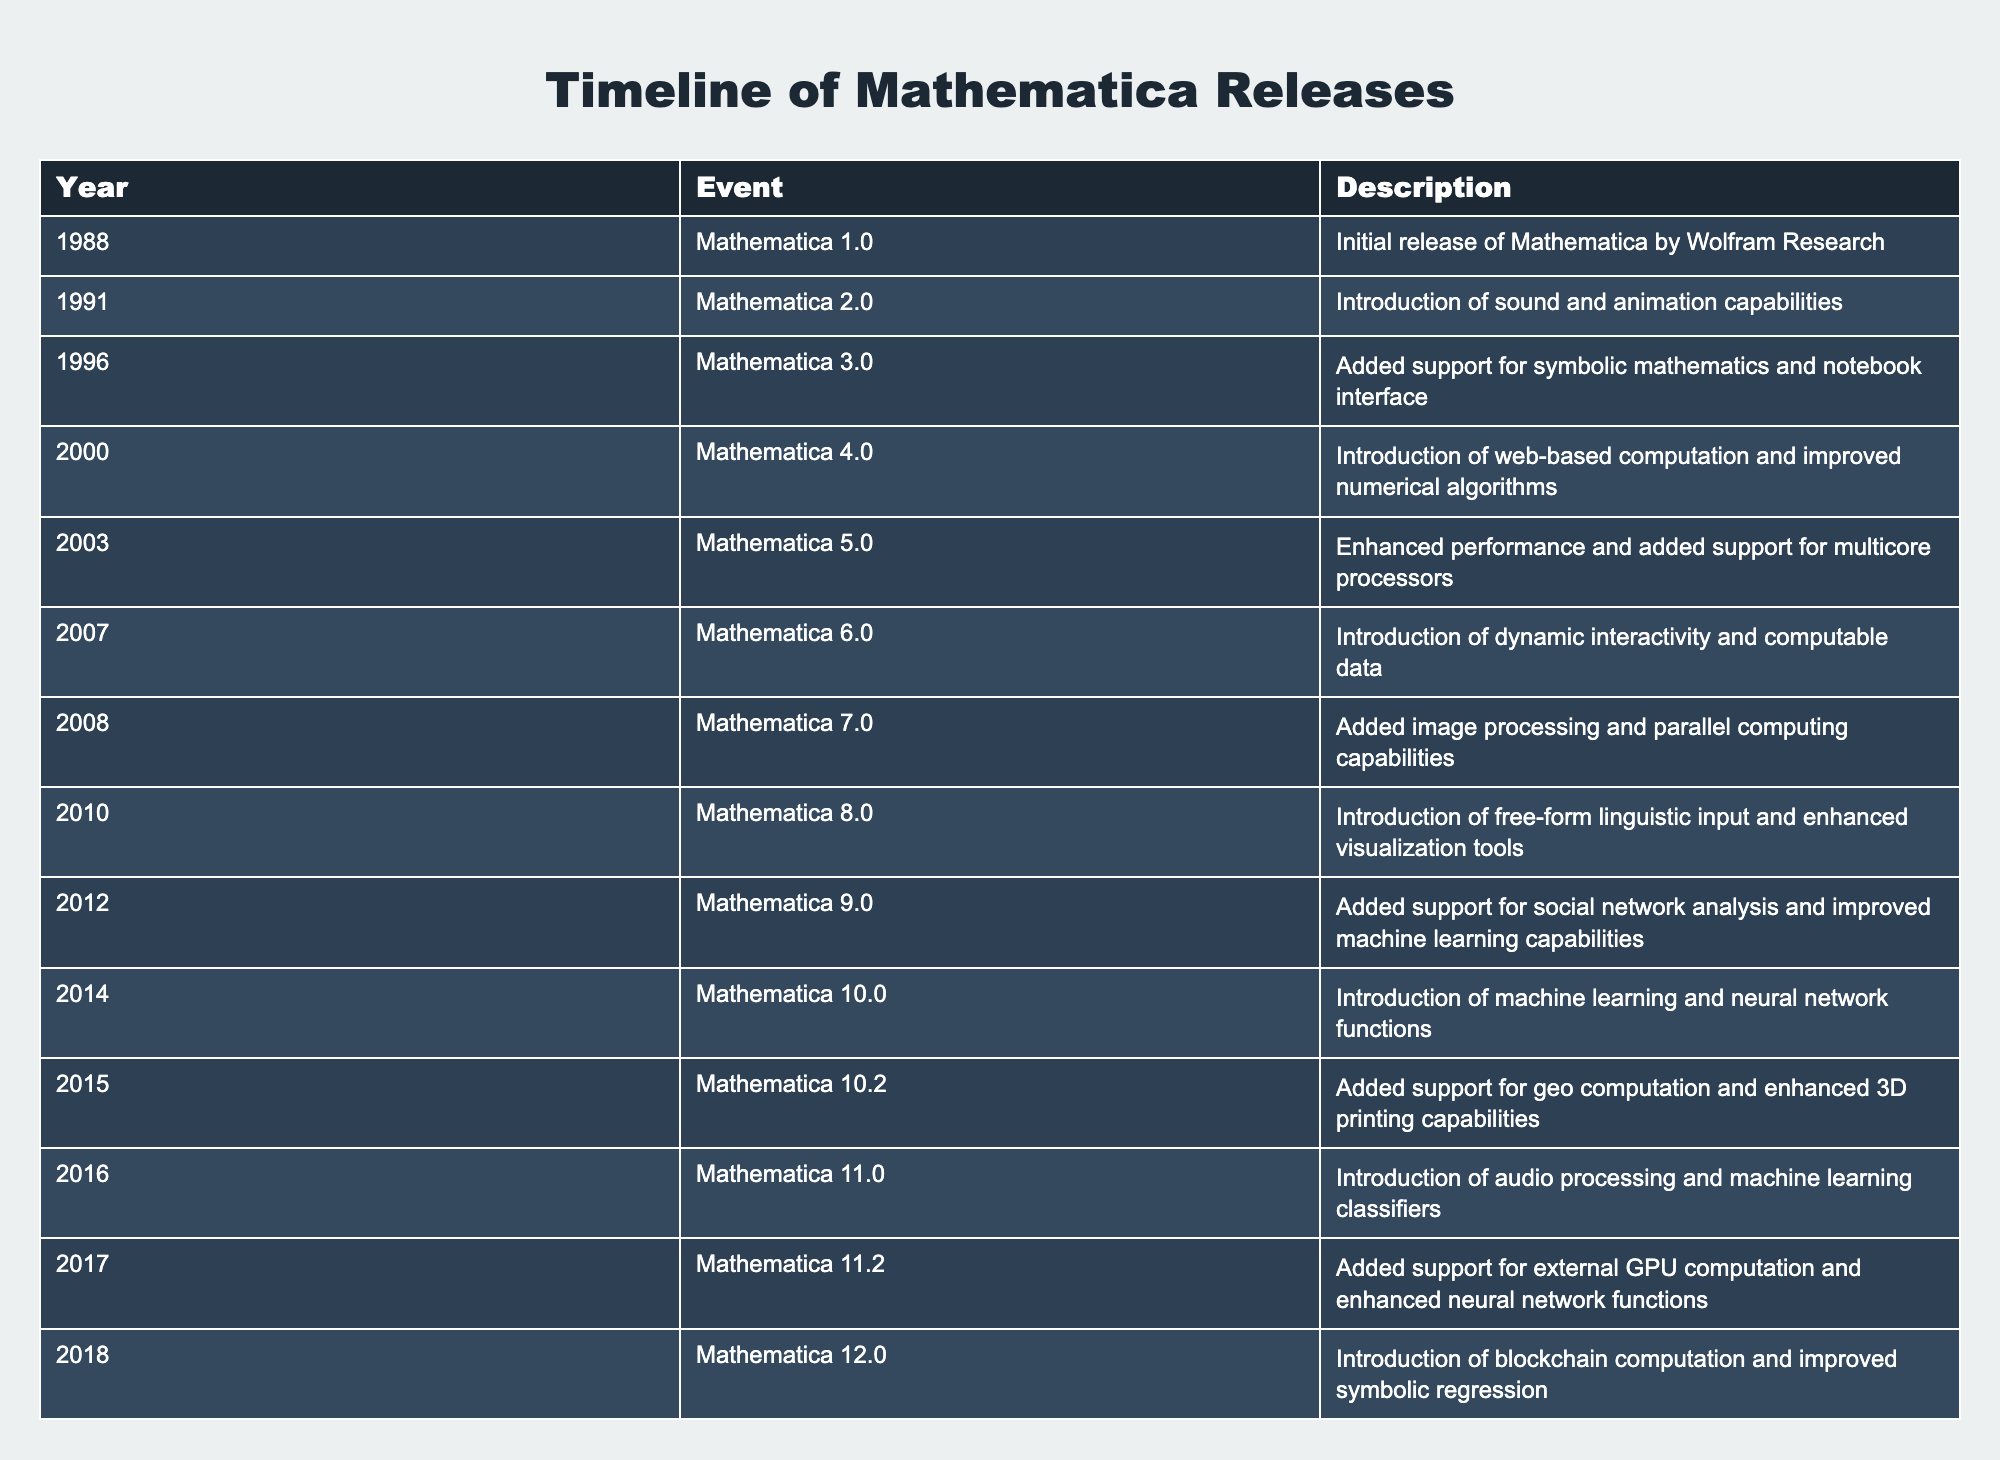What year was Mathematica 3.0 released? The table lists the years of release for various versions of Mathematica. In the row for Mathematica 3.0, the year is given as 1996.
Answer: 1996 What major feature was introduced in Mathematica 10.0? The table states that Mathematica 10.0 introduced machine learning and neural network functions.
Answer: Machine learning and neural network functions Which version of Mathematica was released in 2012? From the table, Mathematica 9.0 is listed under the year 2012.
Answer: Mathematica 9.0 How many versions of Mathematica were released between 2000 and 2010? The table shows releases from 2000 (Mathematica 4.0) to 2010 (Mathematica 8.0). Counting the versions listed in this range gives a total of 7 releases (4.0, 5.0, 6.0, 7.0, 8.0).
Answer: 7 Was Mathematica 11.2 released after Mathematica 12.0? From the timeline, Mathematica 11.2 was released in 2017 and Mathematica 12.0 in 2018, indicating that 11.2 was indeed released before 12.0.
Answer: No What is the most recent version mentioned in the timeline? The table lists the most recent version as Mathematica 13.1, which was released in 2022.
Answer: Mathematica 13.1 Which feature was added in Mathematica 12.2? The timeline notes that advanced machine learning capabilities and improved cloud integration were introduced in Mathematica 12.2.
Answer: Advanced machine learning capabilities and improved cloud integration How many updates included the introduction of machine learning? The table notes that Mathematica 10.0, 10.2, and 11.0 introduced machine learning features. Counting these gives a total of 3 updates that mentioned machine learning.
Answer: 3 What types of capabilities were introduced from Mathematica 6.0 to 12.0? From the table, the versions during this period introduced dynamic interactivity (6.0), image processing and parallel computing (7.0), free-form linguistic input (8.0), social network analysis (9.0), machine learning functions (10.0), and advanced machine learning capabilities (12.2). This can be summarized as various interactive, computational, and analysis capabilities.
Answer: Various interactive, computational, and analysis capabilities 